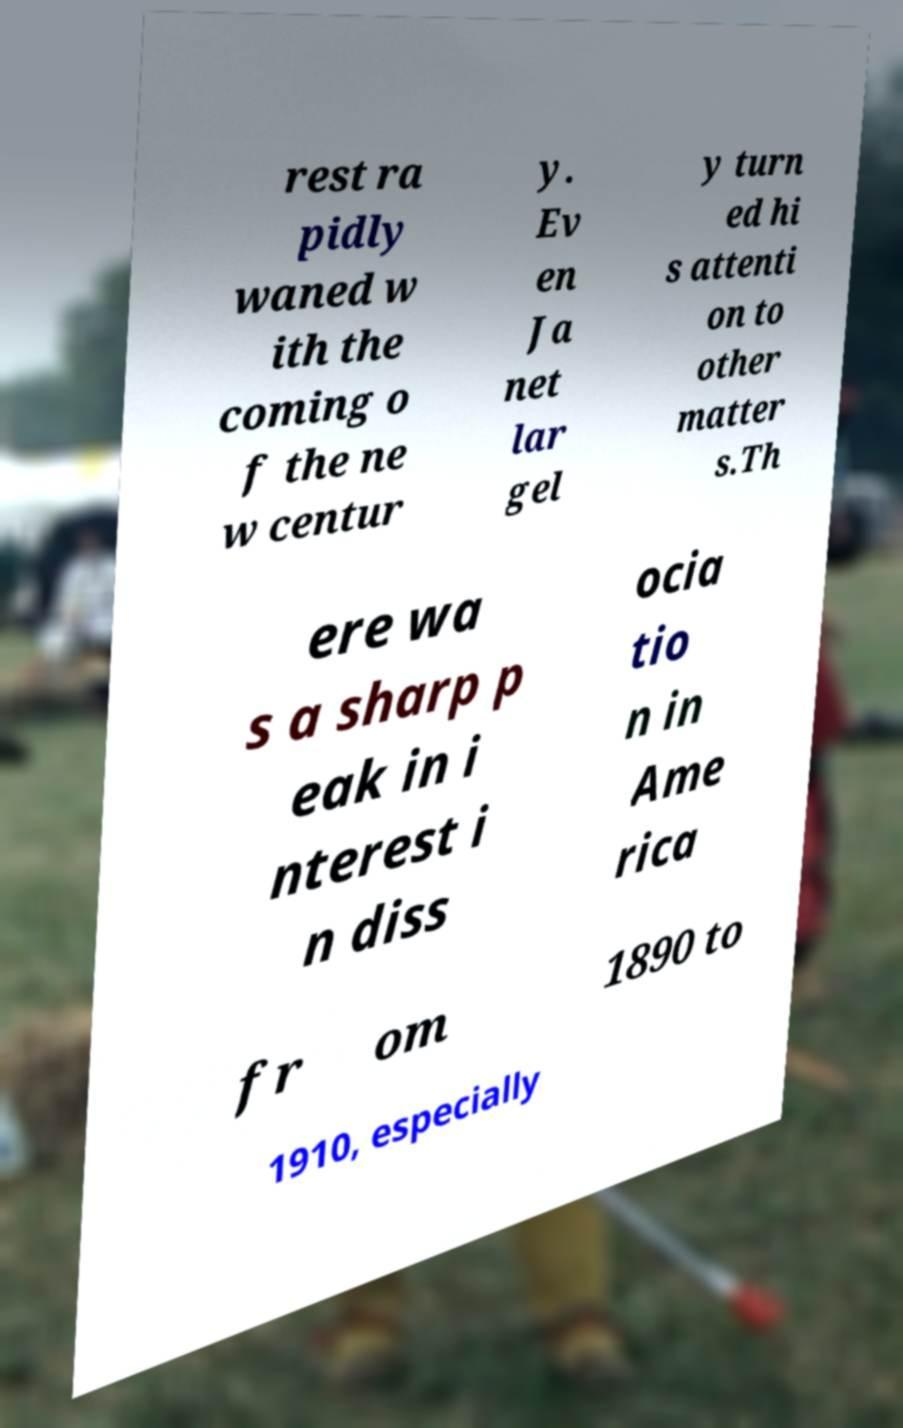Could you extract and type out the text from this image? rest ra pidly waned w ith the coming o f the ne w centur y. Ev en Ja net lar gel y turn ed hi s attenti on to other matter s.Th ere wa s a sharp p eak in i nterest i n diss ocia tio n in Ame rica fr om 1890 to 1910, especially 